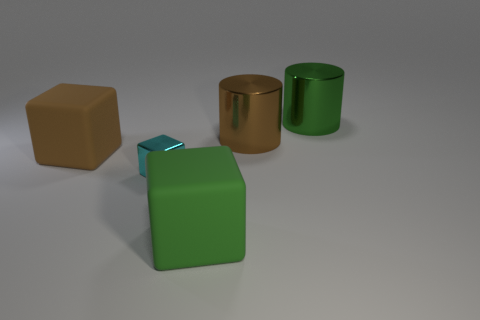What's the relative size of the small blue cube compared to the other objects? The small blue cube is significantly smaller than the other objects. It looks like it could be approximately one-third the height of the larger green object it's resting upon. 